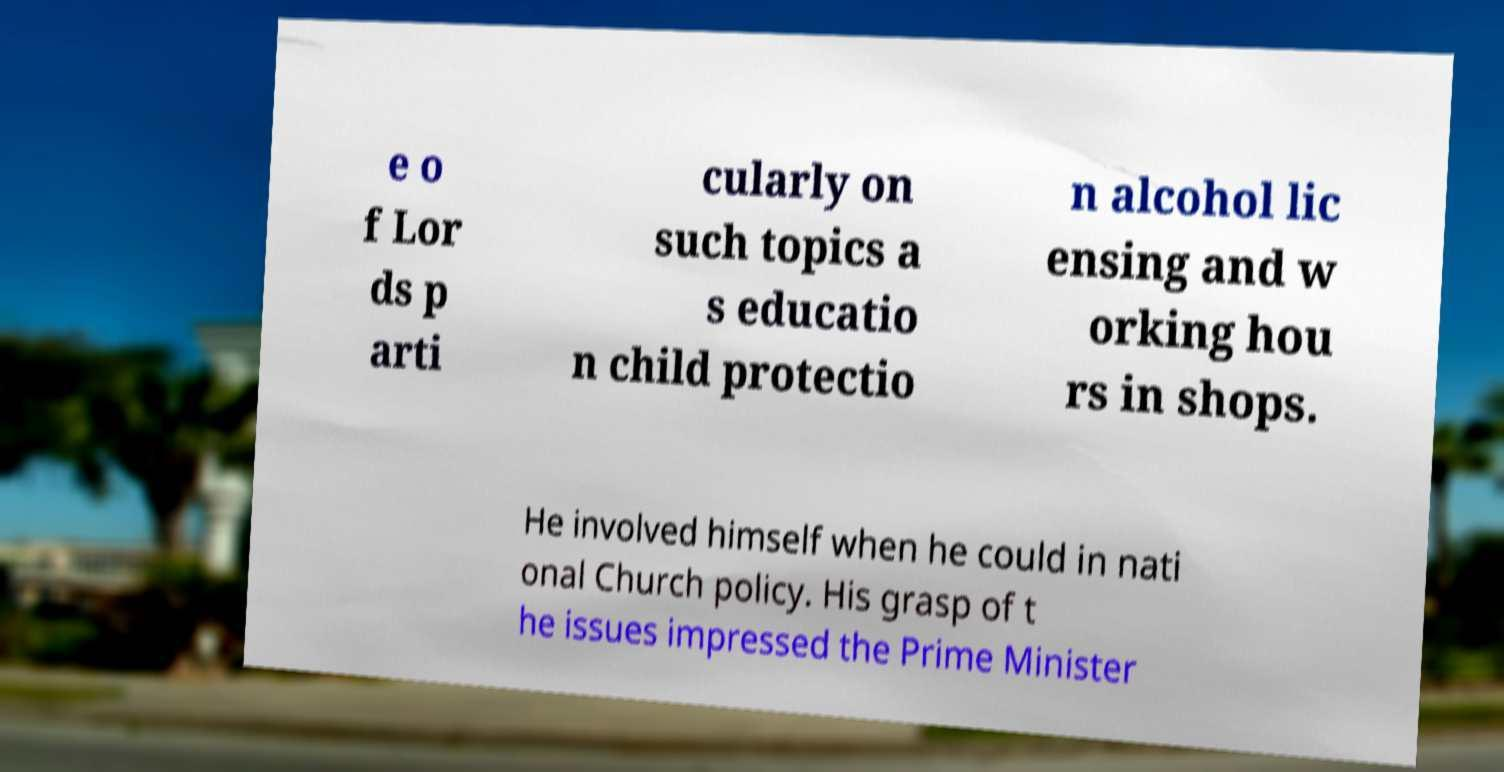For documentation purposes, I need the text within this image transcribed. Could you provide that? e o f Lor ds p arti cularly on such topics a s educatio n child protectio n alcohol lic ensing and w orking hou rs in shops. He involved himself when he could in nati onal Church policy. His grasp of t he issues impressed the Prime Minister 